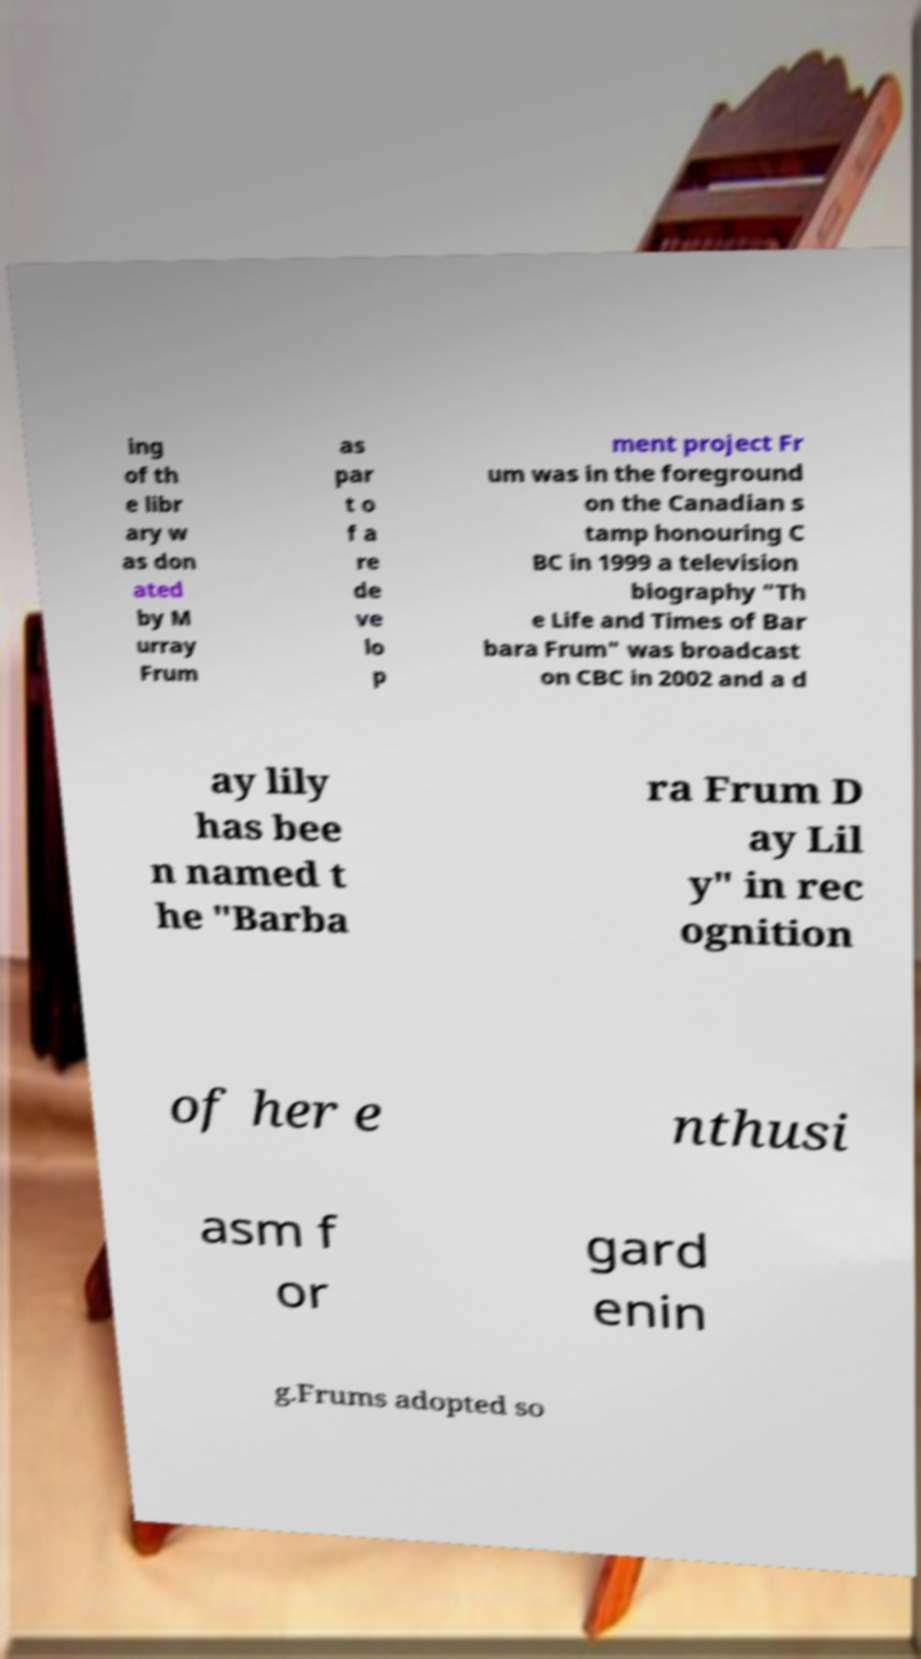Could you assist in decoding the text presented in this image and type it out clearly? ing of th e libr ary w as don ated by M urray Frum as par t o f a re de ve lo p ment project Fr um was in the foreground on the Canadian s tamp honouring C BC in 1999 a television biography "Th e Life and Times of Bar bara Frum" was broadcast on CBC in 2002 and a d ay lily has bee n named t he "Barba ra Frum D ay Lil y" in rec ognition of her e nthusi asm f or gard enin g.Frums adopted so 